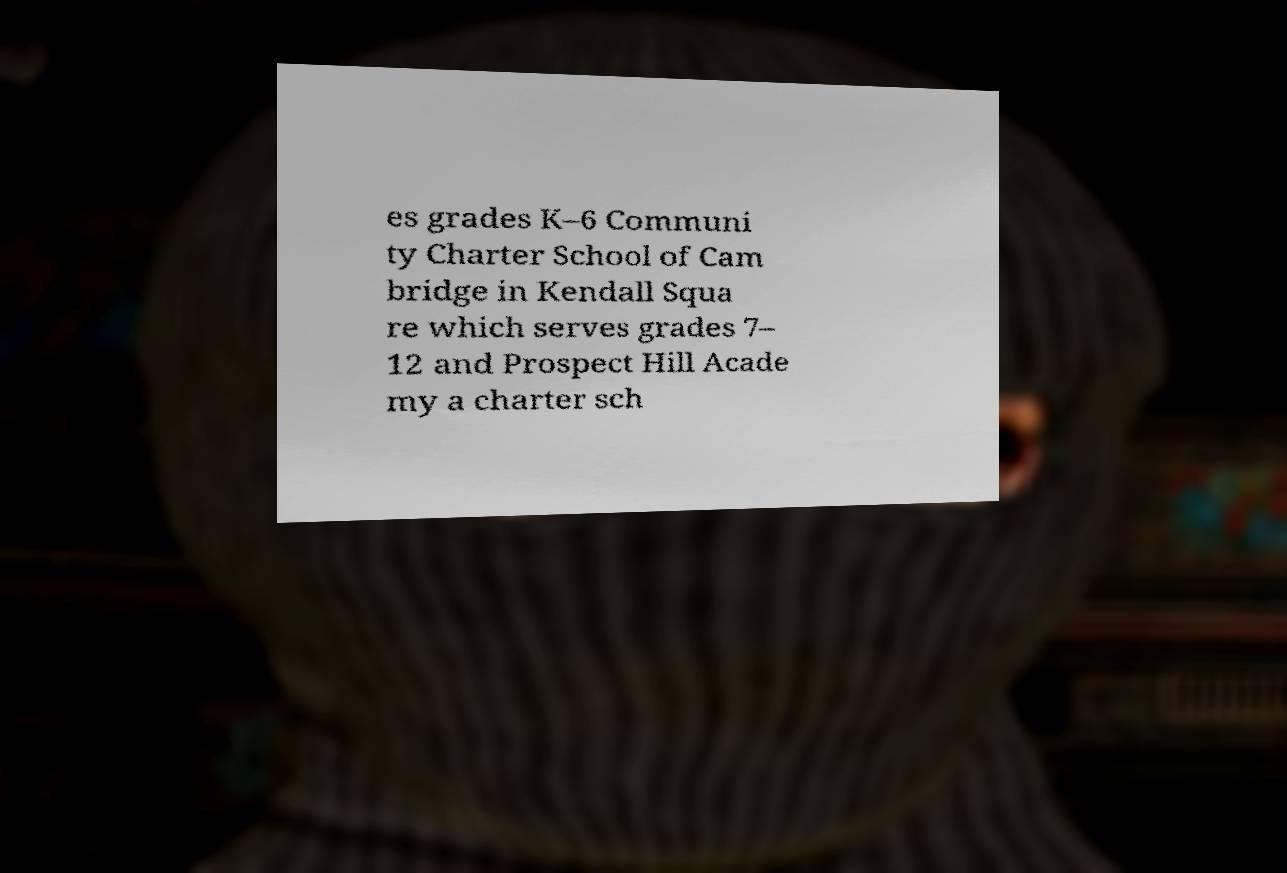I need the written content from this picture converted into text. Can you do that? es grades K–6 Communi ty Charter School of Cam bridge in Kendall Squa re which serves grades 7– 12 and Prospect Hill Acade my a charter sch 